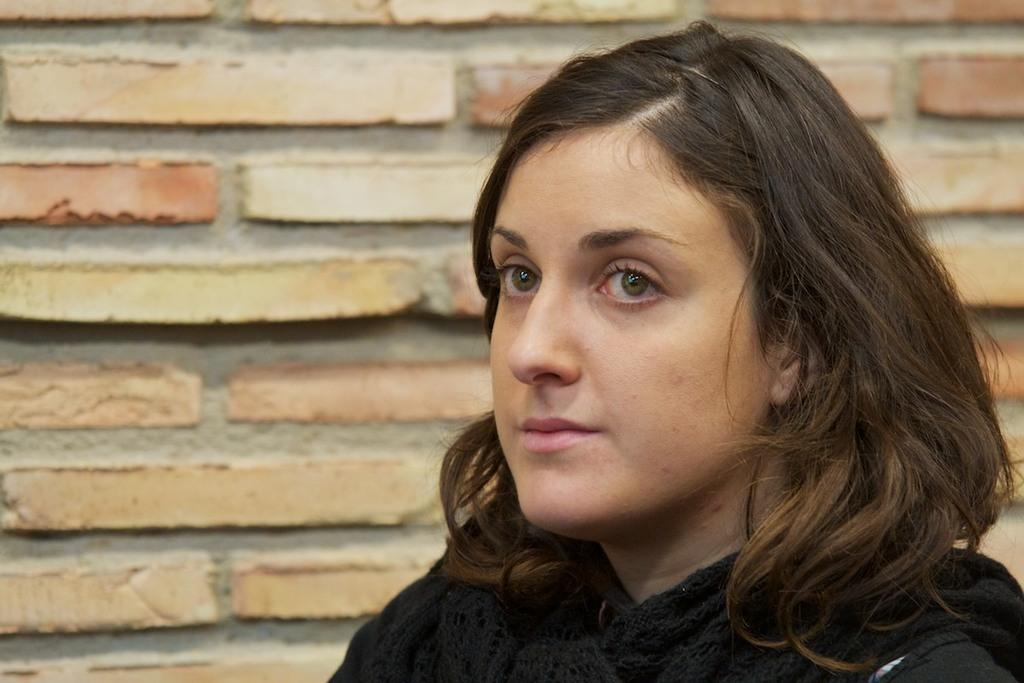Who is present in the image? There is a woman in the picture. What can be seen in the background of the image? There is a brick wall in the background of the picture. What type of sock is the woman wearing in the image? There is no information about the woman's socks in the image, so it cannot be determined. 